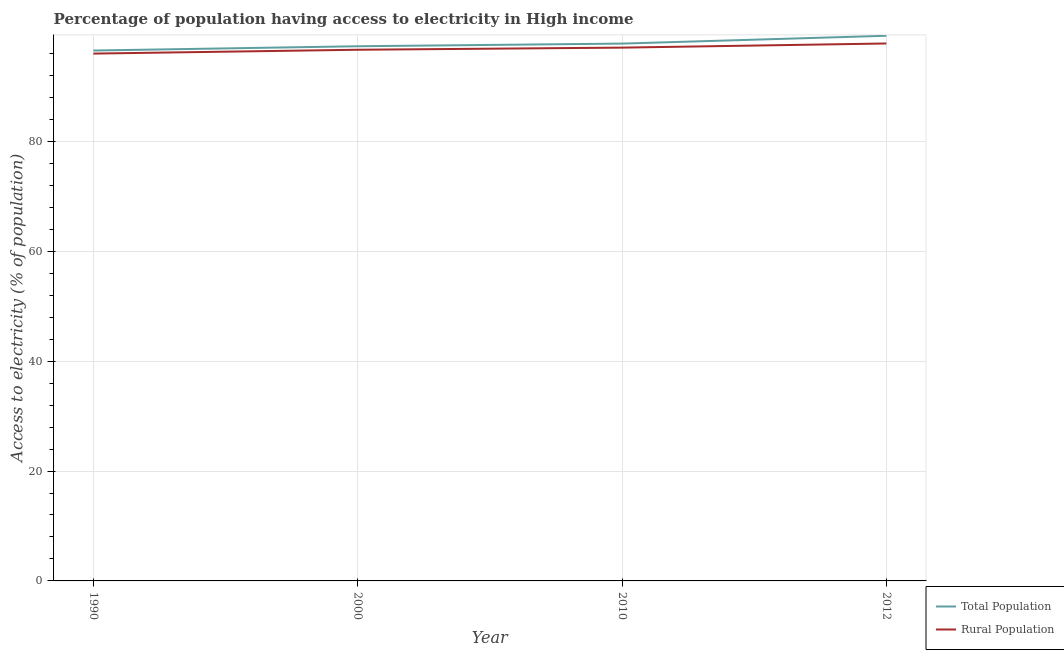Is the number of lines equal to the number of legend labels?
Offer a terse response. Yes. What is the percentage of rural population having access to electricity in 2000?
Your answer should be very brief. 96.68. Across all years, what is the maximum percentage of rural population having access to electricity?
Provide a succinct answer. 97.82. Across all years, what is the minimum percentage of rural population having access to electricity?
Ensure brevity in your answer.  95.98. In which year was the percentage of rural population having access to electricity maximum?
Your response must be concise. 2012. What is the total percentage of rural population having access to electricity in the graph?
Give a very brief answer. 387.53. What is the difference between the percentage of population having access to electricity in 2000 and that in 2012?
Give a very brief answer. -1.91. What is the difference between the percentage of population having access to electricity in 2010 and the percentage of rural population having access to electricity in 2000?
Offer a terse response. 1.12. What is the average percentage of rural population having access to electricity per year?
Ensure brevity in your answer.  96.88. In the year 2012, what is the difference between the percentage of population having access to electricity and percentage of rural population having access to electricity?
Your answer should be compact. 1.41. In how many years, is the percentage of rural population having access to electricity greater than 88 %?
Offer a terse response. 4. What is the ratio of the percentage of rural population having access to electricity in 1990 to that in 2012?
Your response must be concise. 0.98. What is the difference between the highest and the second highest percentage of rural population having access to electricity?
Offer a very short reply. 0.75. What is the difference between the highest and the lowest percentage of rural population having access to electricity?
Ensure brevity in your answer.  1.84. In how many years, is the percentage of rural population having access to electricity greater than the average percentage of rural population having access to electricity taken over all years?
Provide a succinct answer. 2. Is the sum of the percentage of population having access to electricity in 2000 and 2012 greater than the maximum percentage of rural population having access to electricity across all years?
Your response must be concise. Yes. Is the percentage of population having access to electricity strictly greater than the percentage of rural population having access to electricity over the years?
Ensure brevity in your answer.  Yes. How many years are there in the graph?
Ensure brevity in your answer.  4. What is the difference between two consecutive major ticks on the Y-axis?
Ensure brevity in your answer.  20. Are the values on the major ticks of Y-axis written in scientific E-notation?
Your answer should be very brief. No. Does the graph contain any zero values?
Your response must be concise. No. Does the graph contain grids?
Your response must be concise. Yes. How many legend labels are there?
Make the answer very short. 2. What is the title of the graph?
Make the answer very short. Percentage of population having access to electricity in High income. What is the label or title of the X-axis?
Provide a succinct answer. Year. What is the label or title of the Y-axis?
Provide a succinct answer. Access to electricity (% of population). What is the Access to electricity (% of population) of Total Population in 1990?
Provide a succinct answer. 96.53. What is the Access to electricity (% of population) in Rural Population in 1990?
Ensure brevity in your answer.  95.98. What is the Access to electricity (% of population) in Total Population in 2000?
Offer a very short reply. 97.31. What is the Access to electricity (% of population) of Rural Population in 2000?
Make the answer very short. 96.68. What is the Access to electricity (% of population) in Total Population in 2010?
Offer a very short reply. 97.8. What is the Access to electricity (% of population) in Rural Population in 2010?
Ensure brevity in your answer.  97.06. What is the Access to electricity (% of population) in Total Population in 2012?
Your answer should be very brief. 99.22. What is the Access to electricity (% of population) in Rural Population in 2012?
Provide a short and direct response. 97.82. Across all years, what is the maximum Access to electricity (% of population) in Total Population?
Offer a very short reply. 99.22. Across all years, what is the maximum Access to electricity (% of population) in Rural Population?
Your answer should be very brief. 97.82. Across all years, what is the minimum Access to electricity (% of population) in Total Population?
Make the answer very short. 96.53. Across all years, what is the minimum Access to electricity (% of population) in Rural Population?
Provide a succinct answer. 95.98. What is the total Access to electricity (% of population) of Total Population in the graph?
Your response must be concise. 390.87. What is the total Access to electricity (% of population) in Rural Population in the graph?
Offer a terse response. 387.53. What is the difference between the Access to electricity (% of population) of Total Population in 1990 and that in 2000?
Offer a terse response. -0.78. What is the difference between the Access to electricity (% of population) in Rural Population in 1990 and that in 2000?
Offer a terse response. -0.7. What is the difference between the Access to electricity (% of population) of Total Population in 1990 and that in 2010?
Offer a terse response. -1.26. What is the difference between the Access to electricity (% of population) in Rural Population in 1990 and that in 2010?
Your answer should be compact. -1.08. What is the difference between the Access to electricity (% of population) in Total Population in 1990 and that in 2012?
Ensure brevity in your answer.  -2.69. What is the difference between the Access to electricity (% of population) in Rural Population in 1990 and that in 2012?
Your answer should be very brief. -1.84. What is the difference between the Access to electricity (% of population) of Total Population in 2000 and that in 2010?
Offer a terse response. -0.48. What is the difference between the Access to electricity (% of population) of Rural Population in 2000 and that in 2010?
Make the answer very short. -0.39. What is the difference between the Access to electricity (% of population) in Total Population in 2000 and that in 2012?
Your response must be concise. -1.91. What is the difference between the Access to electricity (% of population) in Rural Population in 2000 and that in 2012?
Make the answer very short. -1.14. What is the difference between the Access to electricity (% of population) in Total Population in 2010 and that in 2012?
Your answer should be very brief. -1.43. What is the difference between the Access to electricity (% of population) of Rural Population in 2010 and that in 2012?
Your answer should be compact. -0.75. What is the difference between the Access to electricity (% of population) in Total Population in 1990 and the Access to electricity (% of population) in Rural Population in 2000?
Give a very brief answer. -0.14. What is the difference between the Access to electricity (% of population) in Total Population in 1990 and the Access to electricity (% of population) in Rural Population in 2010?
Ensure brevity in your answer.  -0.53. What is the difference between the Access to electricity (% of population) in Total Population in 1990 and the Access to electricity (% of population) in Rural Population in 2012?
Give a very brief answer. -1.28. What is the difference between the Access to electricity (% of population) in Total Population in 2000 and the Access to electricity (% of population) in Rural Population in 2010?
Provide a short and direct response. 0.25. What is the difference between the Access to electricity (% of population) in Total Population in 2000 and the Access to electricity (% of population) in Rural Population in 2012?
Ensure brevity in your answer.  -0.5. What is the difference between the Access to electricity (% of population) in Total Population in 2010 and the Access to electricity (% of population) in Rural Population in 2012?
Keep it short and to the point. -0.02. What is the average Access to electricity (% of population) of Total Population per year?
Keep it short and to the point. 97.72. What is the average Access to electricity (% of population) in Rural Population per year?
Keep it short and to the point. 96.88. In the year 1990, what is the difference between the Access to electricity (% of population) in Total Population and Access to electricity (% of population) in Rural Population?
Keep it short and to the point. 0.56. In the year 2000, what is the difference between the Access to electricity (% of population) in Total Population and Access to electricity (% of population) in Rural Population?
Make the answer very short. 0.64. In the year 2010, what is the difference between the Access to electricity (% of population) of Total Population and Access to electricity (% of population) of Rural Population?
Make the answer very short. 0.73. In the year 2012, what is the difference between the Access to electricity (% of population) in Total Population and Access to electricity (% of population) in Rural Population?
Provide a succinct answer. 1.41. What is the ratio of the Access to electricity (% of population) of Total Population in 1990 to that in 2010?
Provide a succinct answer. 0.99. What is the ratio of the Access to electricity (% of population) in Total Population in 1990 to that in 2012?
Give a very brief answer. 0.97. What is the ratio of the Access to electricity (% of population) of Rural Population in 1990 to that in 2012?
Give a very brief answer. 0.98. What is the ratio of the Access to electricity (% of population) of Total Population in 2000 to that in 2012?
Keep it short and to the point. 0.98. What is the ratio of the Access to electricity (% of population) in Rural Population in 2000 to that in 2012?
Your answer should be very brief. 0.99. What is the ratio of the Access to electricity (% of population) of Total Population in 2010 to that in 2012?
Your answer should be very brief. 0.99. What is the difference between the highest and the second highest Access to electricity (% of population) of Total Population?
Ensure brevity in your answer.  1.43. What is the difference between the highest and the second highest Access to electricity (% of population) of Rural Population?
Your answer should be compact. 0.75. What is the difference between the highest and the lowest Access to electricity (% of population) of Total Population?
Make the answer very short. 2.69. What is the difference between the highest and the lowest Access to electricity (% of population) of Rural Population?
Your answer should be very brief. 1.84. 